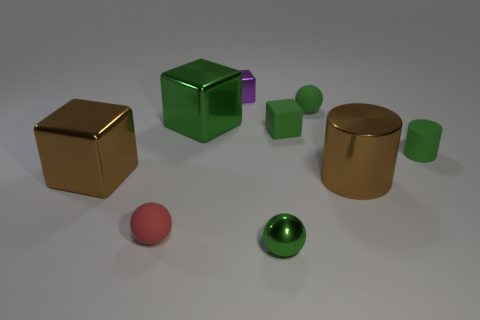Subtract all yellow spheres. Subtract all blue cylinders. How many spheres are left? 3 Add 1 tiny matte cubes. How many objects exist? 10 Subtract all spheres. How many objects are left? 6 Add 2 cylinders. How many cylinders are left? 4 Add 5 big metal spheres. How many big metal spheres exist? 5 Subtract 0 yellow balls. How many objects are left? 9 Subtract all green cubes. Subtract all gray cubes. How many objects are left? 7 